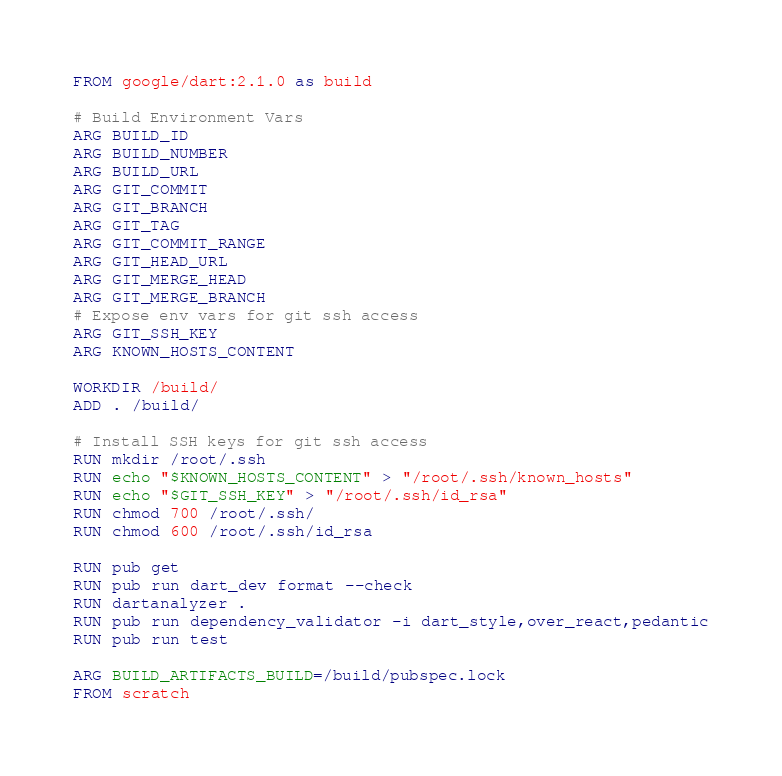Convert code to text. <code><loc_0><loc_0><loc_500><loc_500><_Dockerfile_>FROM google/dart:2.1.0 as build

# Build Environment Vars
ARG BUILD_ID
ARG BUILD_NUMBER
ARG BUILD_URL
ARG GIT_COMMIT
ARG GIT_BRANCH
ARG GIT_TAG
ARG GIT_COMMIT_RANGE
ARG GIT_HEAD_URL
ARG GIT_MERGE_HEAD
ARG GIT_MERGE_BRANCH
# Expose env vars for git ssh access
ARG GIT_SSH_KEY
ARG KNOWN_HOSTS_CONTENT

WORKDIR /build/
ADD . /build/

# Install SSH keys for git ssh access
RUN mkdir /root/.ssh
RUN echo "$KNOWN_HOSTS_CONTENT" > "/root/.ssh/known_hosts"
RUN echo "$GIT_SSH_KEY" > "/root/.ssh/id_rsa"
RUN chmod 700 /root/.ssh/
RUN chmod 600 /root/.ssh/id_rsa

RUN pub get
RUN pub run dart_dev format --check
RUN dartanalyzer .
RUN pub run dependency_validator -i dart_style,over_react,pedantic
RUN pub run test

ARG BUILD_ARTIFACTS_BUILD=/build/pubspec.lock
FROM scratch</code> 